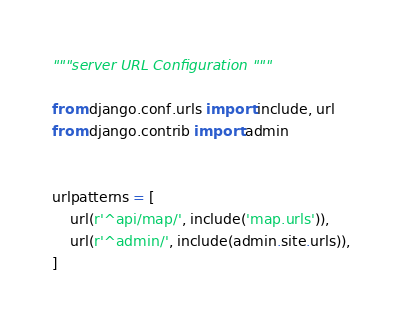Convert code to text. <code><loc_0><loc_0><loc_500><loc_500><_Python_>"""server URL Configuration """

from django.conf.urls import include, url
from django.contrib import admin


urlpatterns = [
    url(r'^api/map/', include('map.urls')),
    url(r'^admin/', include(admin.site.urls)),
]</code> 